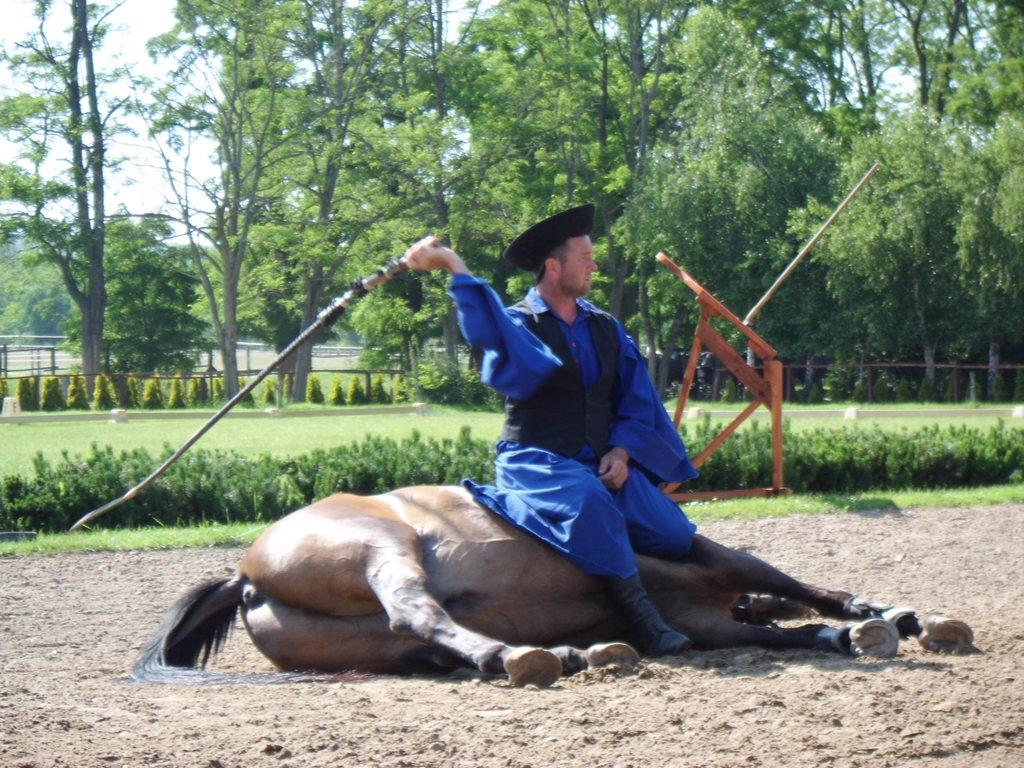Who is the main subject in the image? There is a man in the image. What is the man doing in the image? The man is sitting on a horse. What can be seen in the background of the image? There are trees visible in the background of the image. Where is the bomb hidden in the image? There is no bomb present in the image. What type of stitch is the man using to ride the horse in the image? The man is sitting on the horse, not using any stitch to ride it. 